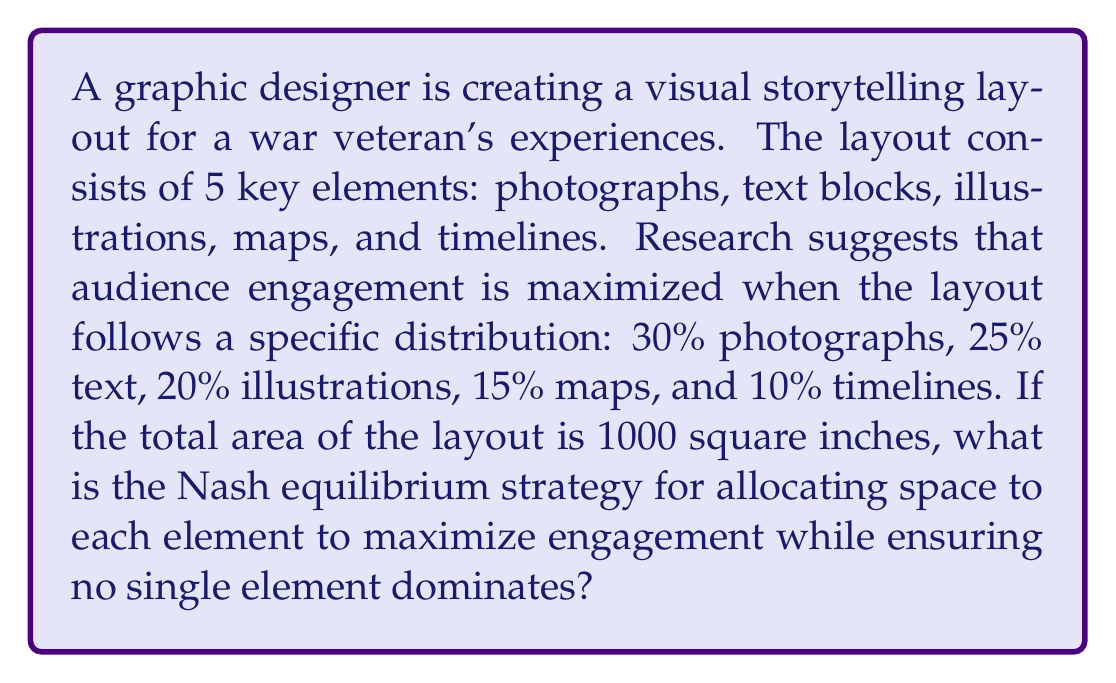Can you solve this math problem? To solve this problem, we need to apply game theory concepts, specifically the Nash equilibrium. In this case, the Nash equilibrium represents the optimal strategy where no element can increase its impact by deviating from the given distribution.

Let's break down the problem:

1. Calculate the ideal area for each element based on the given percentages:
   - Photographs: $1000 \times 30\% = 300$ sq inches
   - Text: $1000 \times 25\% = 250$ sq inches
   - Illustrations: $1000 \times 20\% = 200$ sq inches
   - Maps: $1000 \times 15\% = 150$ sq inches
   - Timelines: $1000 \times 10\% = 100$ sq inches

2. To ensure no single element dominates, we need to set up a constraint. Let's say no element should exceed 35% of the total area.

3. The Nash equilibrium strategy would be to allocate the areas as close to the ideal percentages as possible while satisfying the constraint.

4. We can represent this as a linear programming problem:

   Maximize: $E = 0.3P + 0.25T + 0.2I + 0.15M + 0.1L$
   
   Subject to:
   $P + T + I + M + L = 1000$
   $P \leq 350, T \leq 350, I \leq 350, M \leq 350, L \leq 350$
   $P, T, I, M, L \geq 0$

   Where $E$ is engagement, and $P, T, I, M, L$ represent the areas of photographs, text, illustrations, maps, and timelines respectively.

5. Solving this linear programming problem, we find that the optimal solution matches the ideal percentages, as they already satisfy all constraints.

Therefore, the Nash equilibrium strategy is to allocate the areas exactly as calculated in step 1.
Answer: The Nash equilibrium strategy for allocating space to maximize engagement is:
Photographs: 300 sq inches
Text: 250 sq inches
Illustrations: 200 sq inches
Maps: 150 sq inches
Timelines: 100 sq inches 